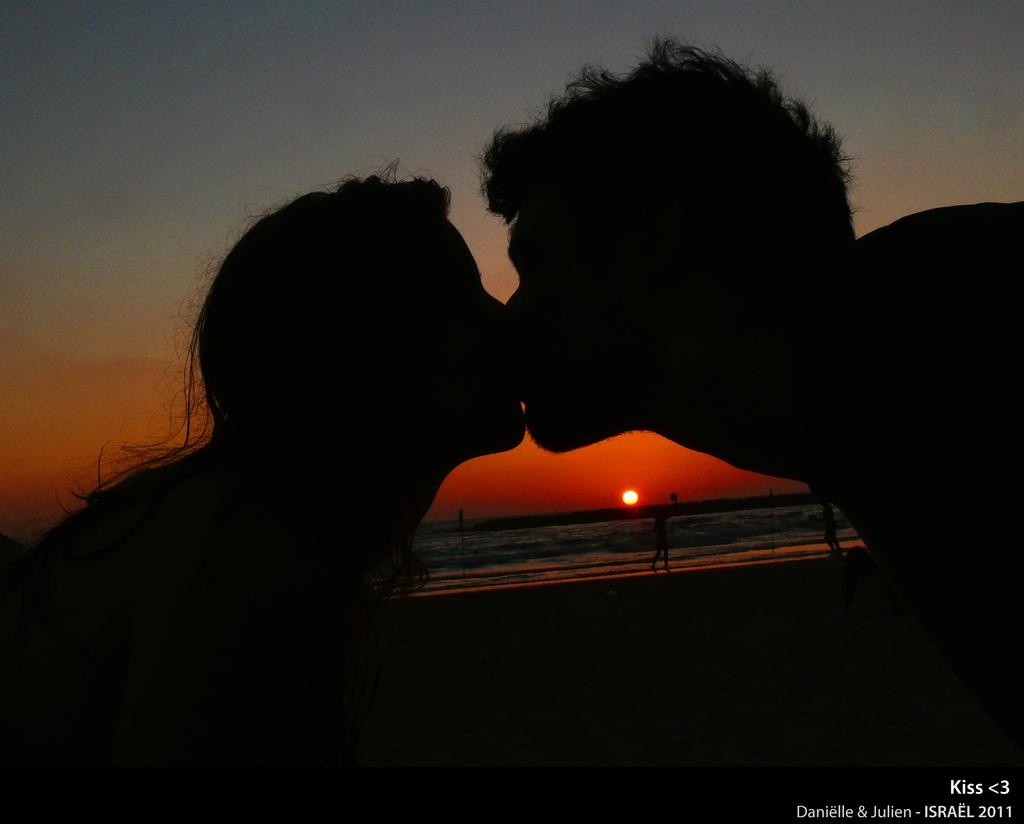What are the two people in the image doing? There is a man and a woman kissing each other in the image. What can be seen in the background of the image? There is sun and water visible in the background of the image, as well as people. What is the purpose of the watermark in the image? The watermark in the bottom right corner of the image is likely for copyright or identification purposes. What type of insurance policy is being discussed by the people in the image? There is no indication in the image that the people are discussing insurance policies. Can you tell me how many yams are visible in the image? There are no yams present in the image. 